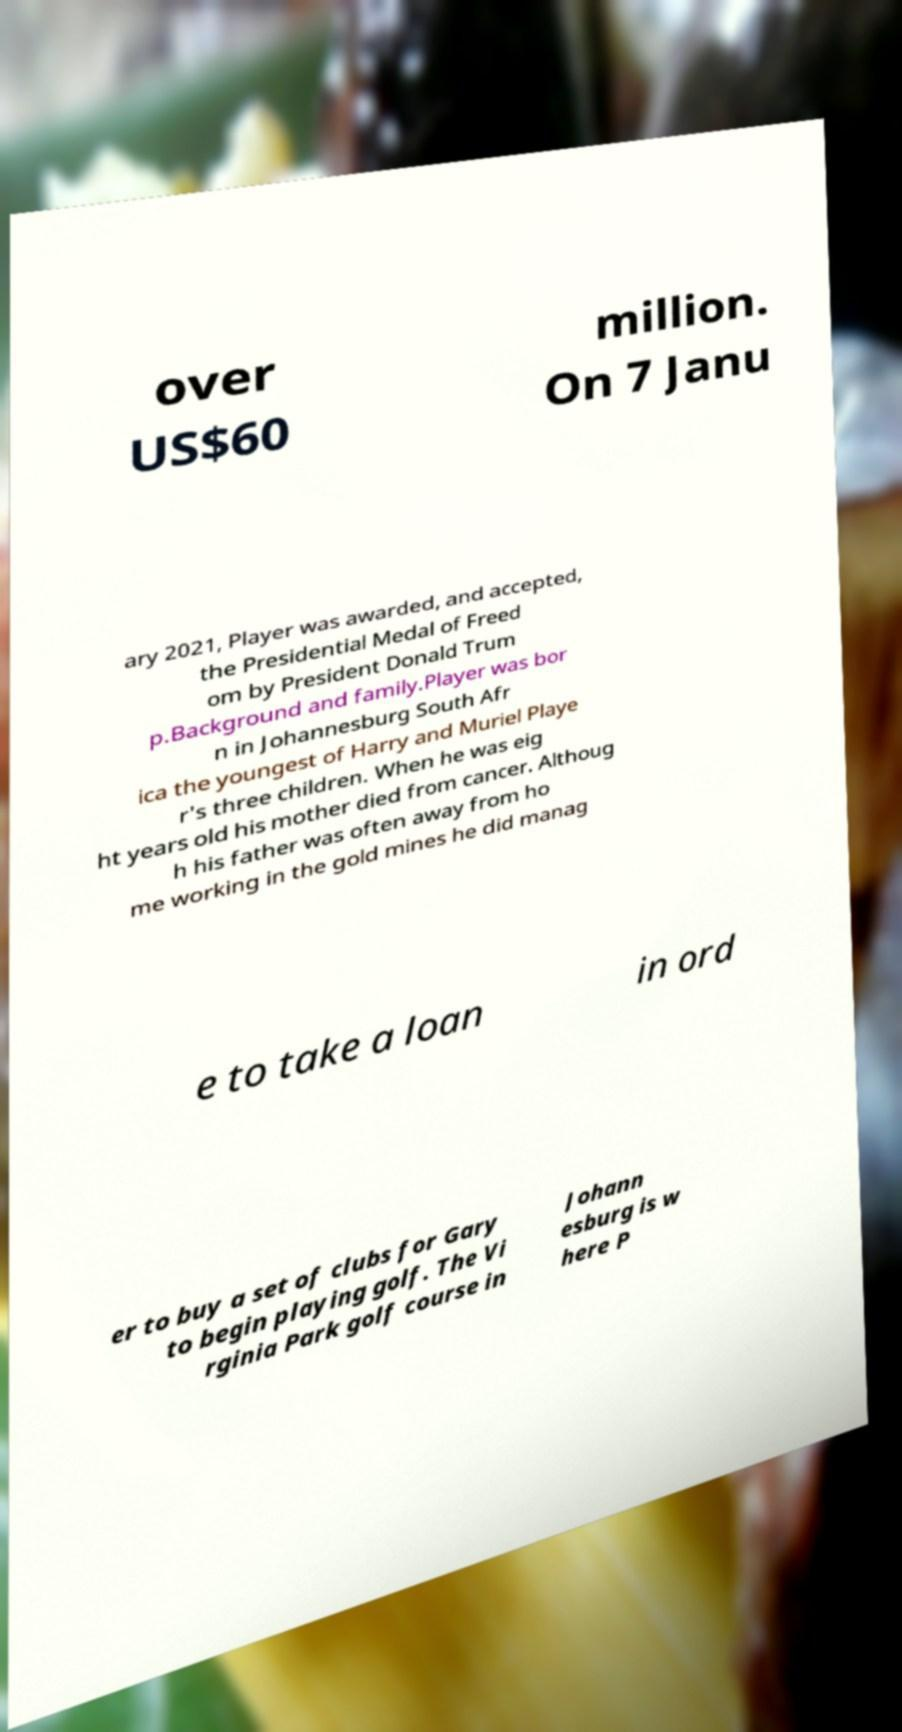Please read and relay the text visible in this image. What does it say? over US$60 million. On 7 Janu ary 2021, Player was awarded, and accepted, the Presidential Medal of Freed om by President Donald Trum p.Background and family.Player was bor n in Johannesburg South Afr ica the youngest of Harry and Muriel Playe r's three children. When he was eig ht years old his mother died from cancer. Althoug h his father was often away from ho me working in the gold mines he did manag e to take a loan in ord er to buy a set of clubs for Gary to begin playing golf. The Vi rginia Park golf course in Johann esburg is w here P 